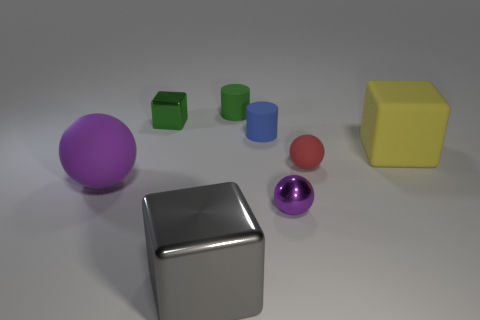Subtract all purple balls. How many were subtracted if there are1purple balls left? 1 Add 2 big gray shiny things. How many objects exist? 10 Subtract all spheres. How many objects are left? 5 Add 1 red matte objects. How many red matte objects exist? 2 Subtract 0 gray cylinders. How many objects are left? 8 Subtract all rubber objects. Subtract all big purple things. How many objects are left? 2 Add 6 blue things. How many blue things are left? 7 